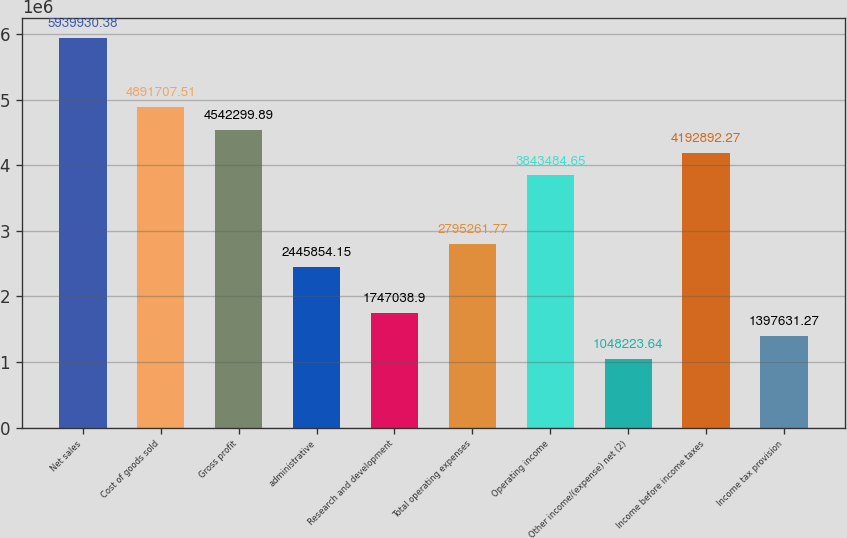Convert chart. <chart><loc_0><loc_0><loc_500><loc_500><bar_chart><fcel>Net sales<fcel>Cost of goods sold<fcel>Gross profit<fcel>administrative<fcel>Research and development<fcel>Total operating expenses<fcel>Operating income<fcel>Other income/(expense) net (2)<fcel>Income before income taxes<fcel>Income tax provision<nl><fcel>5.93993e+06<fcel>4.89171e+06<fcel>4.5423e+06<fcel>2.44585e+06<fcel>1.74704e+06<fcel>2.79526e+06<fcel>3.84348e+06<fcel>1.04822e+06<fcel>4.19289e+06<fcel>1.39763e+06<nl></chart> 